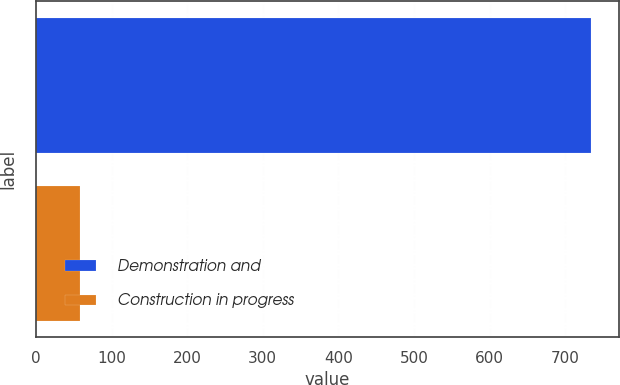<chart> <loc_0><loc_0><loc_500><loc_500><bar_chart><fcel>Demonstration and<fcel>Construction in progress<nl><fcel>734<fcel>58<nl></chart> 